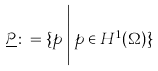<formula> <loc_0><loc_0><loc_500><loc_500>\underline { \mathcal { P } } \colon = \{ p \, \Big | \, p \in H ^ { 1 } ( \Omega ) \}</formula> 